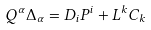<formula> <loc_0><loc_0><loc_500><loc_500>Q ^ { \alpha } \Delta _ { \alpha } = D _ { i } P ^ { i } + L ^ { k } C _ { k }</formula> 